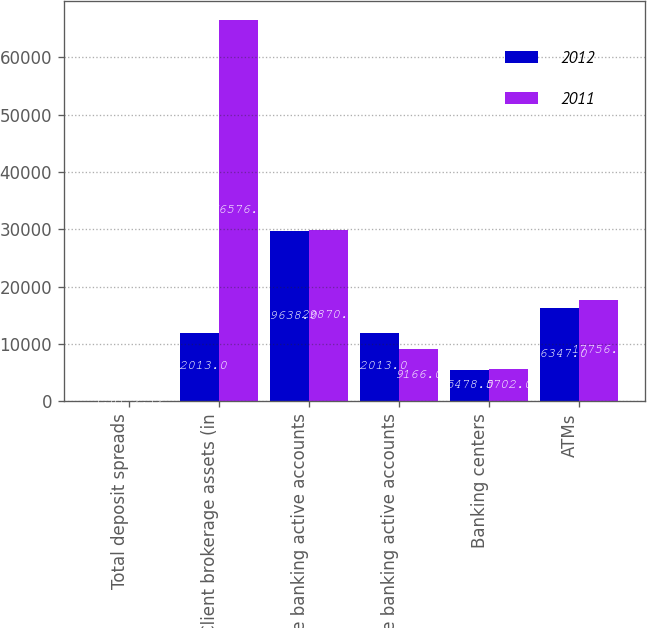Convert chart to OTSL. <chart><loc_0><loc_0><loc_500><loc_500><stacked_bar_chart><ecel><fcel>Total deposit spreads<fcel>Client brokerage assets (in<fcel>Online banking active accounts<fcel>Mobile banking active accounts<fcel>Banking centers<fcel>ATMs<nl><fcel>2012<fcel>1.81<fcel>12013<fcel>29638<fcel>12013<fcel>5478<fcel>16347<nl><fcel>2011<fcel>2.12<fcel>66576<fcel>29870<fcel>9166<fcel>5702<fcel>17756<nl></chart> 